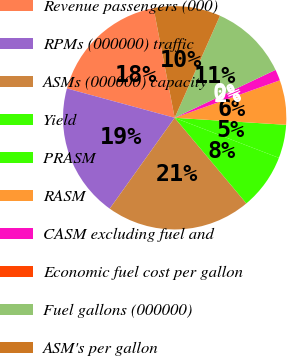Convert chart to OTSL. <chart><loc_0><loc_0><loc_500><loc_500><pie_chart><fcel>Revenue passengers (000)<fcel>RPMs (000000) traffic<fcel>ASMs (000000) capacity<fcel>Yield<fcel>PRASM<fcel>RASM<fcel>CASM excluding fuel and<fcel>Economic fuel cost per gallon<fcel>Fuel gallons (000000)<fcel>ASM's per gallon<nl><fcel>17.74%<fcel>19.35%<fcel>20.97%<fcel>8.06%<fcel>4.84%<fcel>6.45%<fcel>1.61%<fcel>0.0%<fcel>11.29%<fcel>9.68%<nl></chart> 